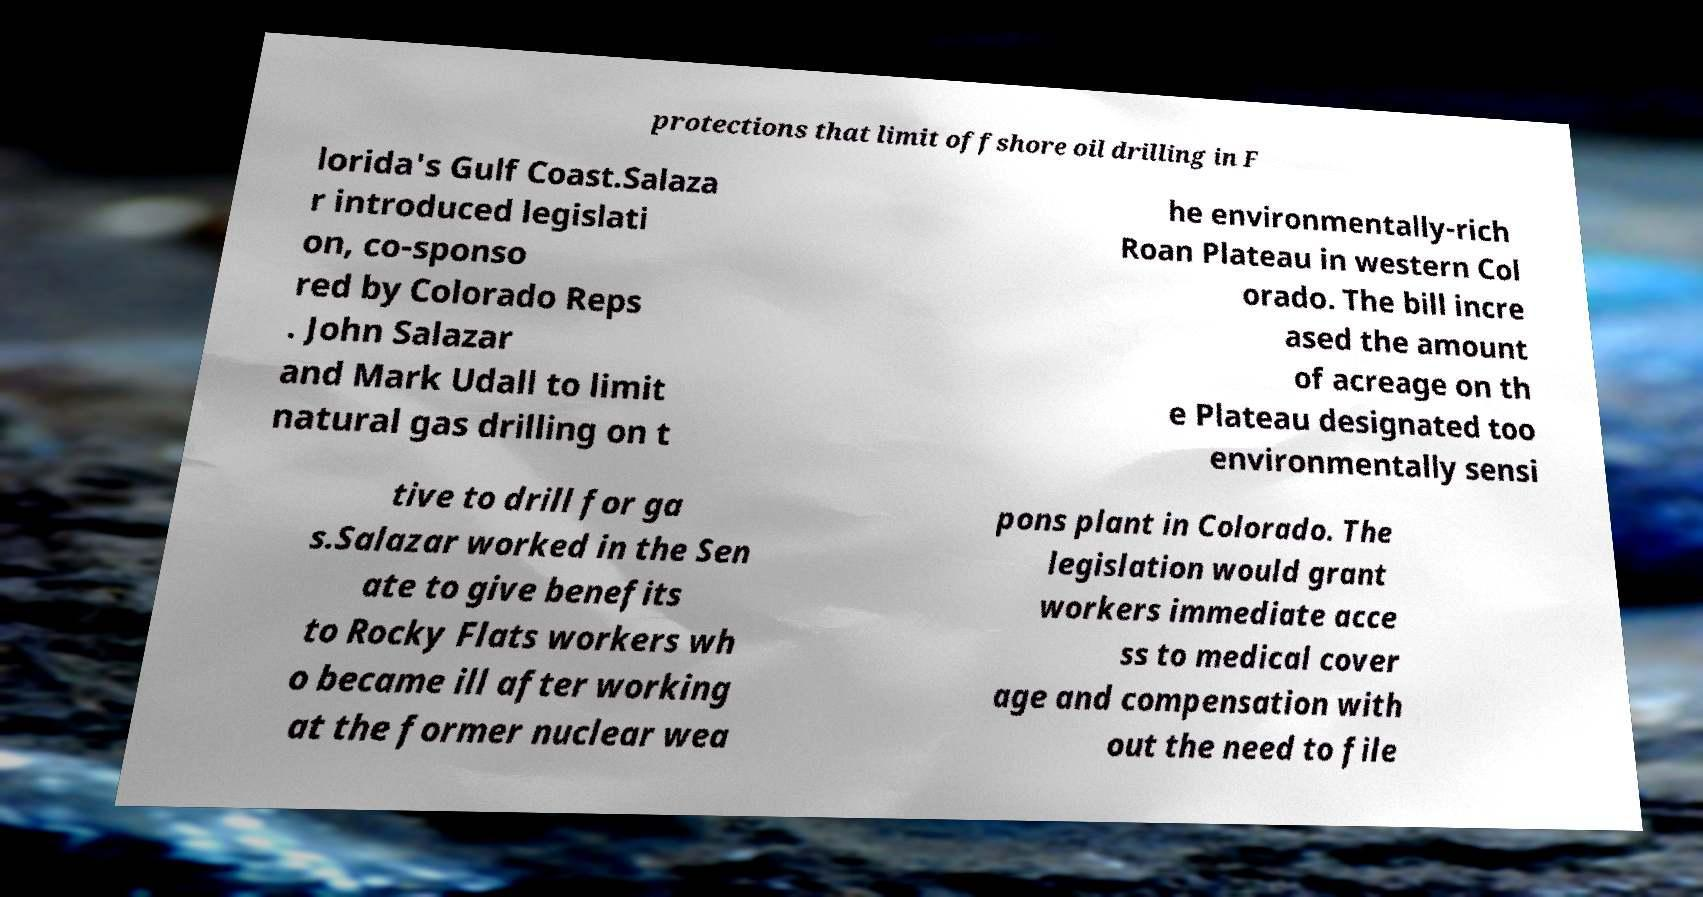Can you read and provide the text displayed in the image?This photo seems to have some interesting text. Can you extract and type it out for me? protections that limit offshore oil drilling in F lorida's Gulf Coast.Salaza r introduced legislati on, co-sponso red by Colorado Reps . John Salazar and Mark Udall to limit natural gas drilling on t he environmentally-rich Roan Plateau in western Col orado. The bill incre ased the amount of acreage on th e Plateau designated too environmentally sensi tive to drill for ga s.Salazar worked in the Sen ate to give benefits to Rocky Flats workers wh o became ill after working at the former nuclear wea pons plant in Colorado. The legislation would grant workers immediate acce ss to medical cover age and compensation with out the need to file 